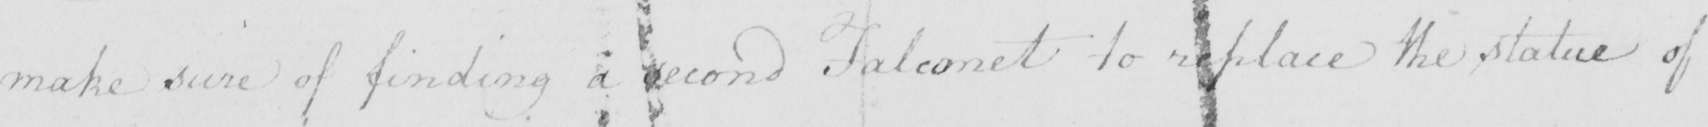Transcribe the text shown in this historical manuscript line. make sure of finding a second Falconet to replace the statue of 